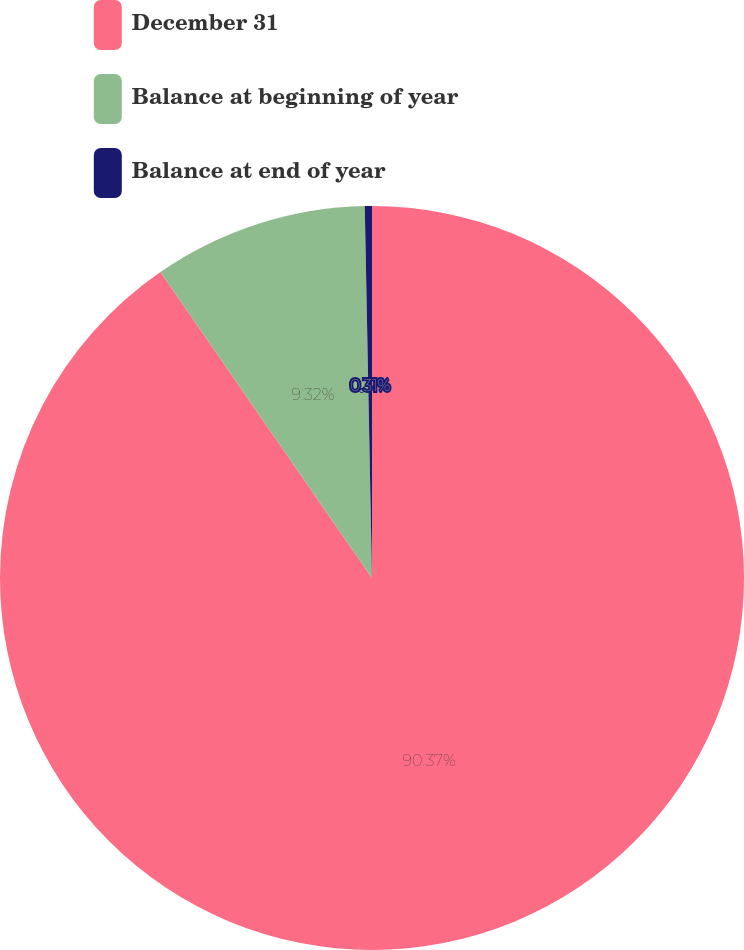<chart> <loc_0><loc_0><loc_500><loc_500><pie_chart><fcel>December 31<fcel>Balance at beginning of year<fcel>Balance at end of year<nl><fcel>90.37%<fcel>9.32%<fcel>0.31%<nl></chart> 